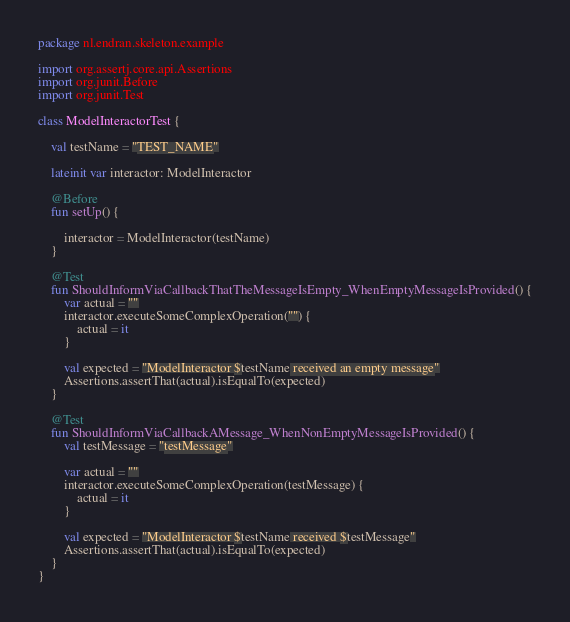Convert code to text. <code><loc_0><loc_0><loc_500><loc_500><_Kotlin_>package nl.endran.skeleton.example

import org.assertj.core.api.Assertions
import org.junit.Before
import org.junit.Test

class ModelInteractorTest {

    val testName = "TEST_NAME"

    lateinit var interactor: ModelInteractor

    @Before
    fun setUp() {

        interactor = ModelInteractor(testName)
    }

    @Test
    fun ShouldInformViaCallbackThatTheMessageIsEmpty_WhenEmptyMessageIsProvided() {
        var actual = ""
        interactor.executeSomeComplexOperation("") {
            actual = it
        }

        val expected = "ModelInteractor $testName received an empty message"
        Assertions.assertThat(actual).isEqualTo(expected)
    }

    @Test
    fun ShouldInformViaCallbackAMessage_WhenNonEmptyMessageIsProvided() {
        val testMessage = "testMessage"

        var actual = ""
        interactor.executeSomeComplexOperation(testMessage) {
            actual = it
        }

        val expected = "ModelInteractor $testName received $testMessage"
        Assertions.assertThat(actual).isEqualTo(expected)
    }
}
</code> 